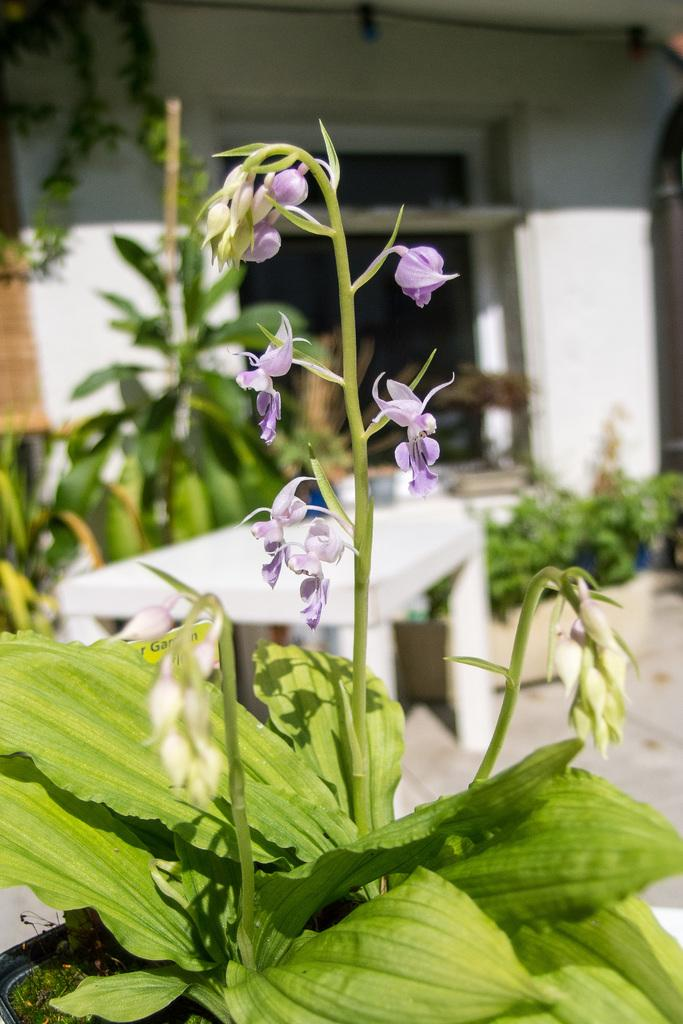What type of flowers can be seen in the image? There are purple color flowers in the image. What are the main parts of the flowers? The flowers have leaves and stems. Can you describe the background of the image? The background of the image is blurred. What structures are present in the image? There is a wall, a window, and a table in the image. What else can be seen in the image besides the flowers? There are plants in the image. What type of development is taking place in the library in the image? There is no library or development present in the image; it features purple color flowers, plants, and a blurred background. Can you tell me how many rocks are visible in the image? There are no rocks visible in the image. 